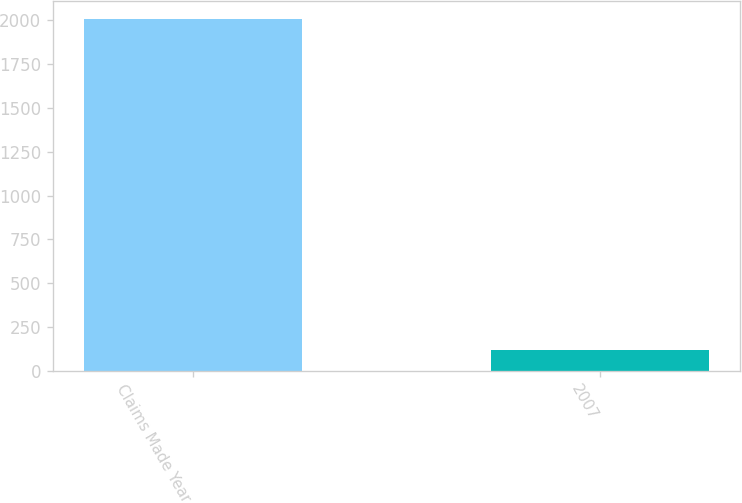Convert chart to OTSL. <chart><loc_0><loc_0><loc_500><loc_500><bar_chart><fcel>Claims Made Year<fcel>2007<nl><fcel>2010<fcel>117<nl></chart> 